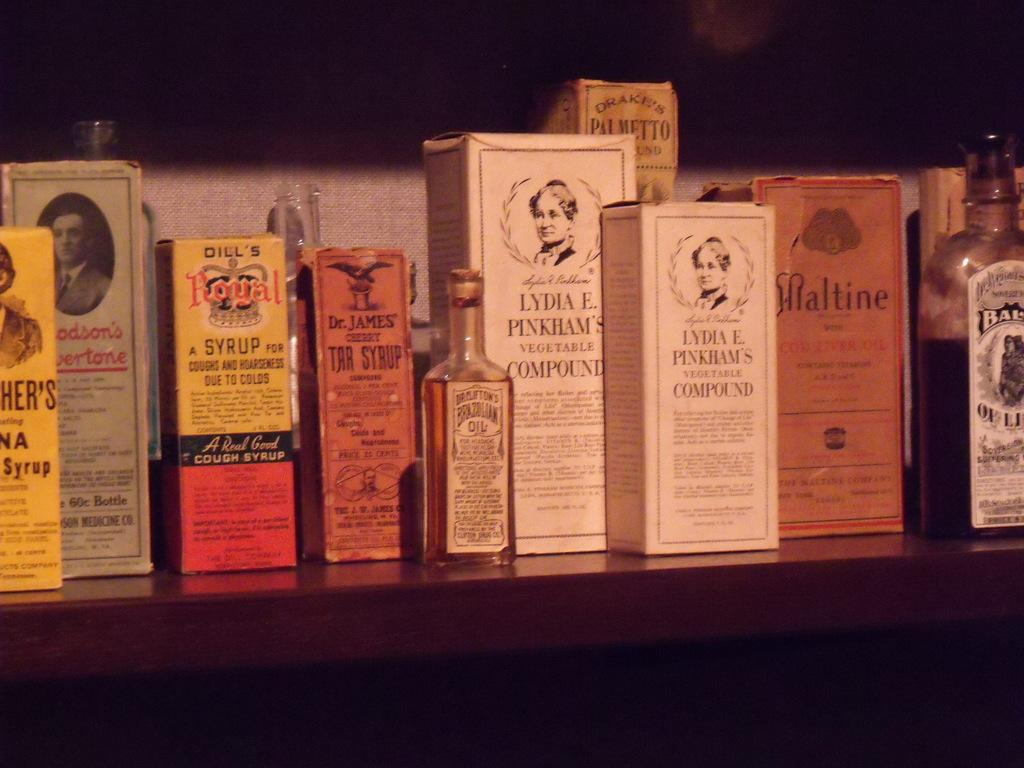Provide a one-sentence caption for the provided image. Vintage medicinal supplies such as Dill's Royal Syrup are displayed on a shelf. 